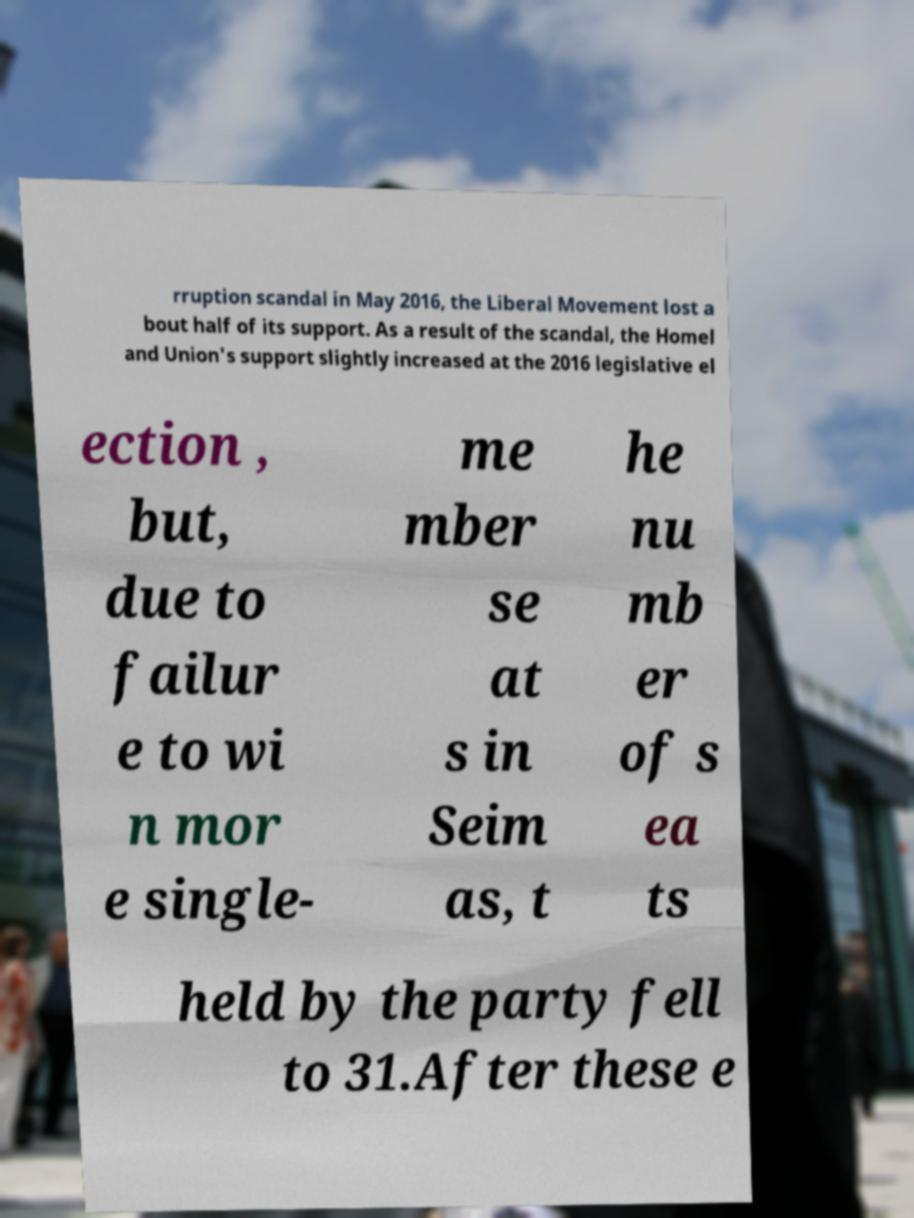For documentation purposes, I need the text within this image transcribed. Could you provide that? rruption scandal in May 2016, the Liberal Movement lost a bout half of its support. As a result of the scandal, the Homel and Union's support slightly increased at the 2016 legislative el ection , but, due to failur e to wi n mor e single- me mber se at s in Seim as, t he nu mb er of s ea ts held by the party fell to 31.After these e 